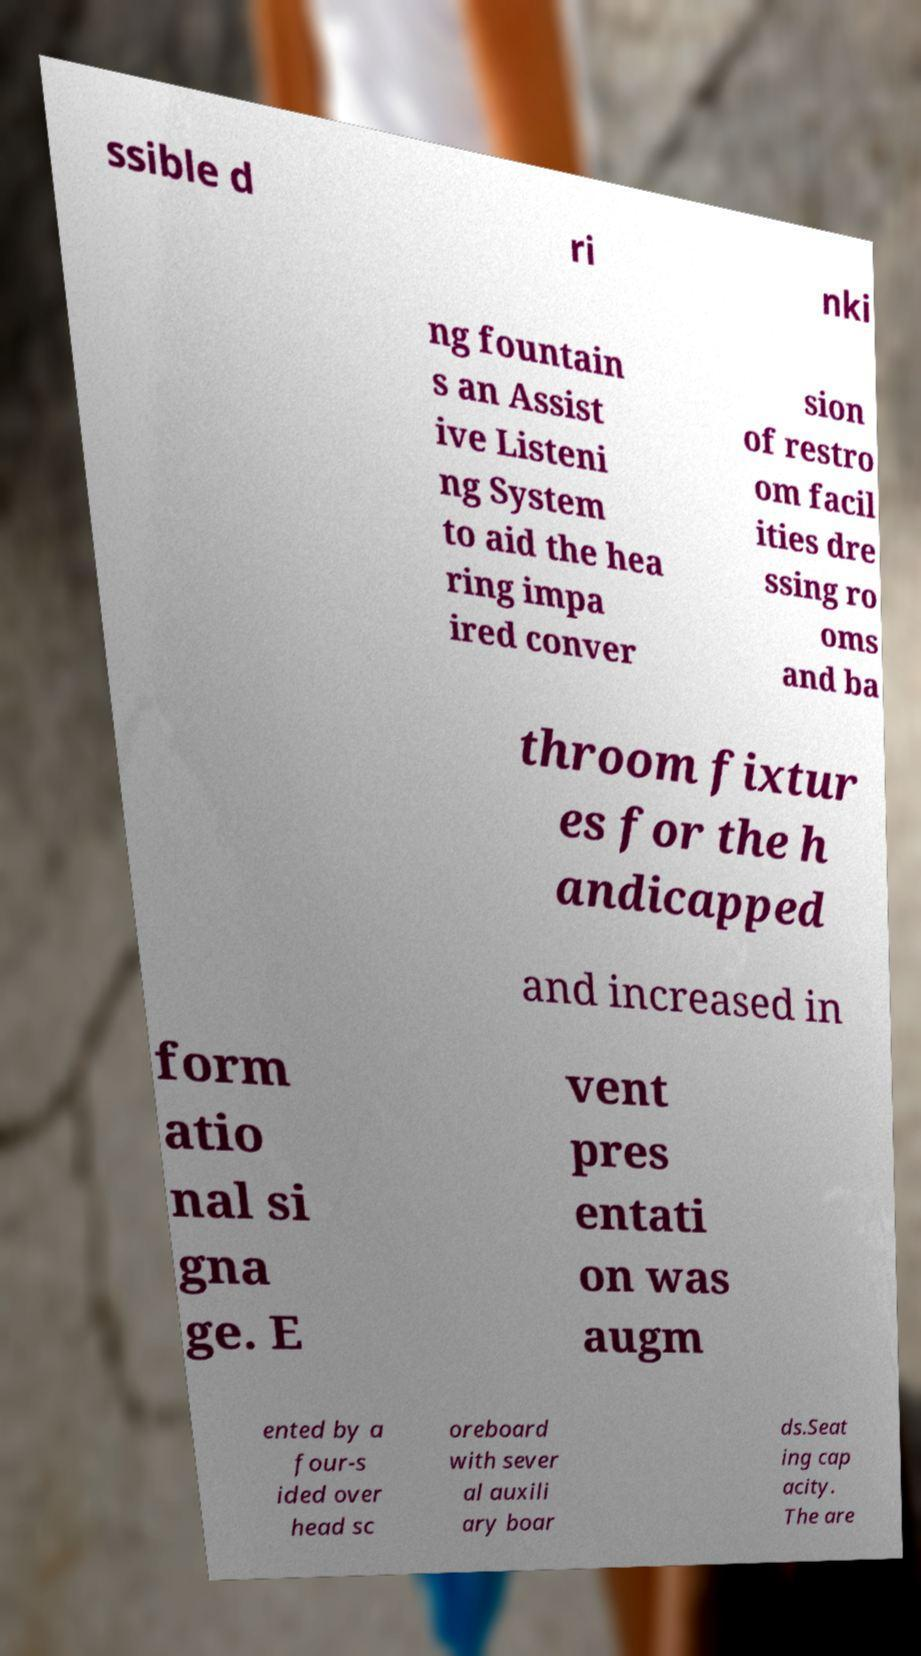Can you accurately transcribe the text from the provided image for me? ssible d ri nki ng fountain s an Assist ive Listeni ng System to aid the hea ring impa ired conver sion of restro om facil ities dre ssing ro oms and ba throom fixtur es for the h andicapped and increased in form atio nal si gna ge. E vent pres entati on was augm ented by a four-s ided over head sc oreboard with sever al auxili ary boar ds.Seat ing cap acity. The are 